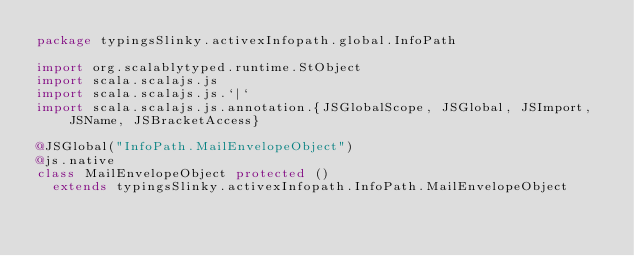<code> <loc_0><loc_0><loc_500><loc_500><_Scala_>package typingsSlinky.activexInfopath.global.InfoPath

import org.scalablytyped.runtime.StObject
import scala.scalajs.js
import scala.scalajs.js.`|`
import scala.scalajs.js.annotation.{JSGlobalScope, JSGlobal, JSImport, JSName, JSBracketAccess}

@JSGlobal("InfoPath.MailEnvelopeObject")
@js.native
class MailEnvelopeObject protected ()
  extends typingsSlinky.activexInfopath.InfoPath.MailEnvelopeObject
</code> 